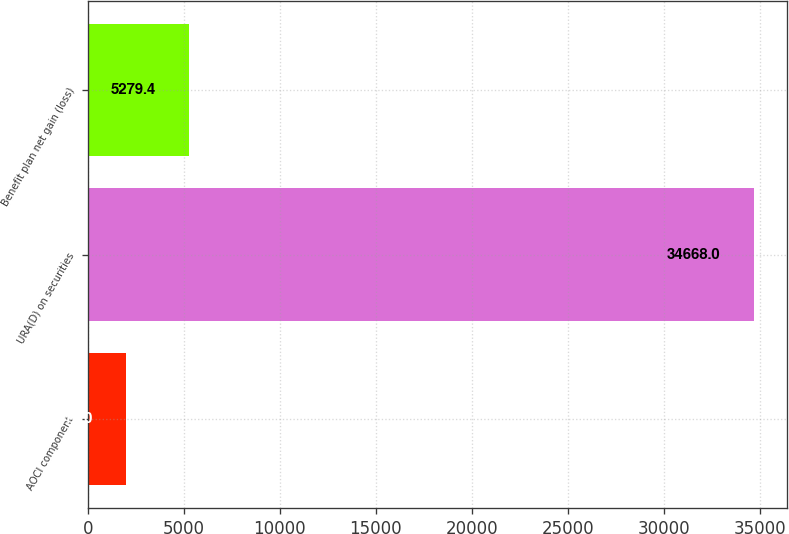<chart> <loc_0><loc_0><loc_500><loc_500><bar_chart><fcel>AOCI component<fcel>URA(D) on securities<fcel>Benefit plan net gain (loss)<nl><fcel>2014<fcel>34668<fcel>5279.4<nl></chart> 